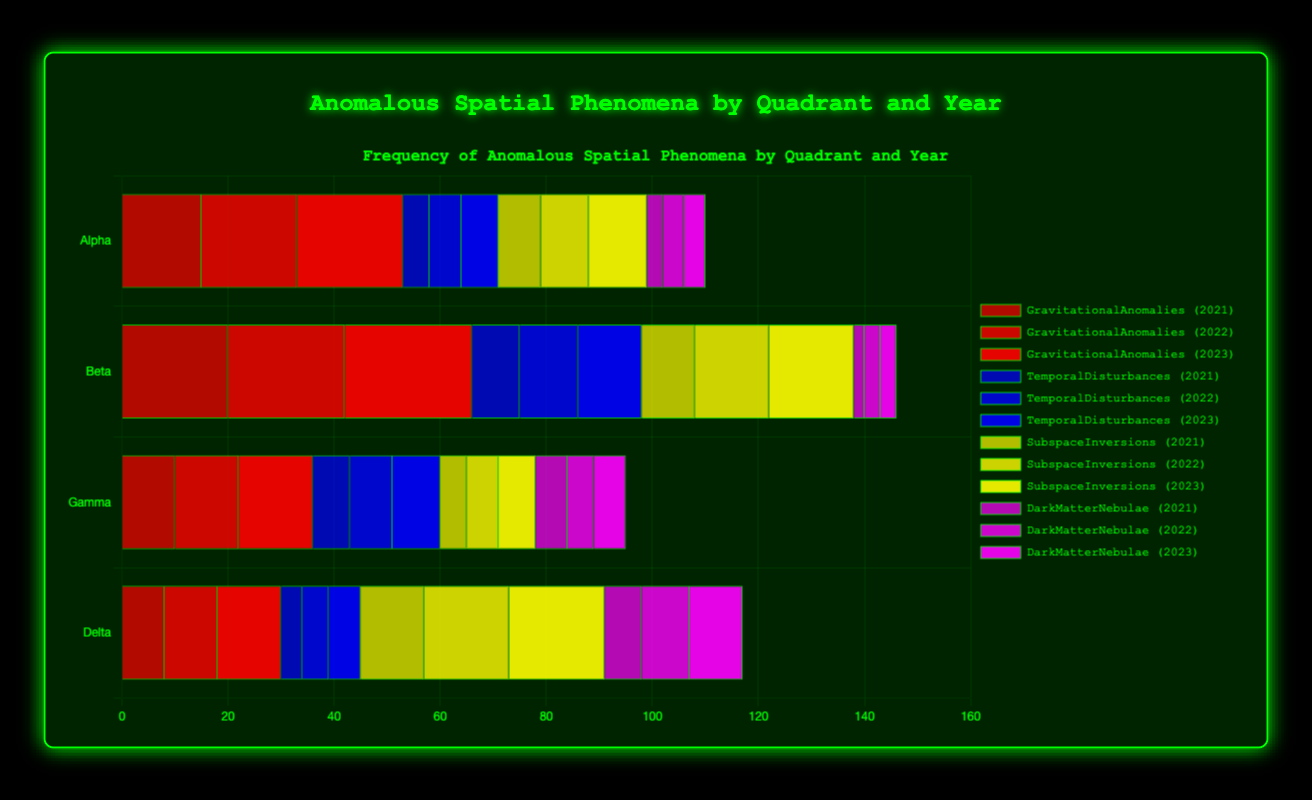Which quadrant experienced the highest number of gravitational anomalies in 2023? By inspecting the bars for gravitational anomalies (red) in 2023, we see that Beta quadrant has the tallest bar.
Answer: Beta How many temporal disturbances were recorded in Gamma quadrant over all years? Sum the temporal disturbances (blue bars) for Gamma quadrant across 2021, 2022, and 2023: 7 + 8 + 9 = 24.
Answer: 24 In which year did Alpha quadrant have the highest number of dark matter nebulae? Examine the pink bars for Alpha quadrant across years. The bar is highest in 2021 and 2023.
Answer: 2023 Is the number of subspace inversions in Delta quadrant greater in 2022 or 2023? Compare the yellow bars for Delta quadrant in 2022 and 2023. The 2023 bar is taller.
Answer: 2023 What is the total number of gravitational anomalies in Beta quadrant from 2021 to 2023? Sum the red bars for Beta quadrant across 2021, 2022, and 2023: 20 + 22 + 24 = 66.
Answer: 66 Which year sees the highest number of temporal disturbances in Beta quadrant? Inspect the blue bars for Beta quadrant. The bar is highest in 2023.
Answer: 2023 Do Alpha and Delta quadrants have equal numbers of dark matter nebulae in 2022? Compare the pink bars for Alpha and Delta quadrants in 2022. Alpha has 4, Delta has 9.
Answer: No How many subspace inversions occurred in total across all quadrants in 2023? Sum the yellow bars for all quadrants in 2023: 11 + 16 + 7 + 18 = 52.
Answer: 52 Which quadrant recorded the fewest temporal disturbances in 2021? Examine the blue bars for each quadrant in 2021. Delta quadrant has the smallest bar.
Answer: Delta What is the difference in the number of subspace inversions between Alpha and Beta quadrants in 2022? Subtract the 2022 yellow bar of Alpha quadrant (9) from Beta quadrant (14): 14 - 9 = 5.
Answer: 5 